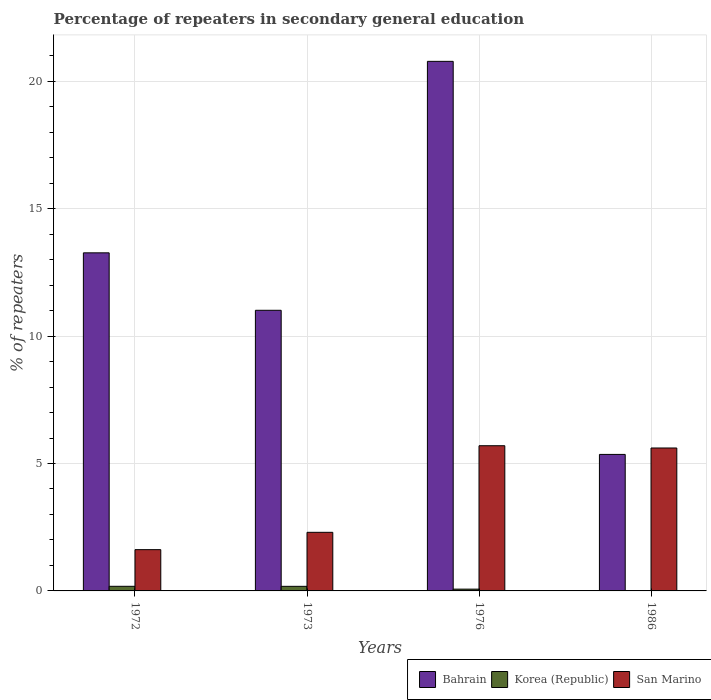Are the number of bars per tick equal to the number of legend labels?
Offer a very short reply. Yes. Are the number of bars on each tick of the X-axis equal?
Your response must be concise. Yes. How many bars are there on the 2nd tick from the right?
Ensure brevity in your answer.  3. In how many cases, is the number of bars for a given year not equal to the number of legend labels?
Make the answer very short. 0. What is the percentage of repeaters in secondary general education in San Marino in 1976?
Your response must be concise. 5.7. Across all years, what is the maximum percentage of repeaters in secondary general education in San Marino?
Your answer should be compact. 5.7. Across all years, what is the minimum percentage of repeaters in secondary general education in Bahrain?
Provide a succinct answer. 5.36. In which year was the percentage of repeaters in secondary general education in San Marino minimum?
Your answer should be very brief. 1972. What is the total percentage of repeaters in secondary general education in Korea (Republic) in the graph?
Your answer should be very brief. 0.44. What is the difference between the percentage of repeaters in secondary general education in Bahrain in 1972 and that in 1973?
Offer a terse response. 2.25. What is the difference between the percentage of repeaters in secondary general education in San Marino in 1986 and the percentage of repeaters in secondary general education in Korea (Republic) in 1972?
Give a very brief answer. 5.43. What is the average percentage of repeaters in secondary general education in Bahrain per year?
Keep it short and to the point. 12.6. In the year 1976, what is the difference between the percentage of repeaters in secondary general education in Korea (Republic) and percentage of repeaters in secondary general education in Bahrain?
Offer a very short reply. -20.71. What is the ratio of the percentage of repeaters in secondary general education in Bahrain in 1973 to that in 1986?
Offer a terse response. 2.06. Is the percentage of repeaters in secondary general education in Bahrain in 1973 less than that in 1986?
Your response must be concise. No. Is the difference between the percentage of repeaters in secondary general education in Korea (Republic) in 1972 and 1976 greater than the difference between the percentage of repeaters in secondary general education in Bahrain in 1972 and 1976?
Give a very brief answer. Yes. What is the difference between the highest and the second highest percentage of repeaters in secondary general education in San Marino?
Make the answer very short. 0.09. What is the difference between the highest and the lowest percentage of repeaters in secondary general education in Bahrain?
Give a very brief answer. 15.42. What does the 1st bar from the right in 1986 represents?
Offer a terse response. San Marino. Is it the case that in every year, the sum of the percentage of repeaters in secondary general education in Bahrain and percentage of repeaters in secondary general education in Korea (Republic) is greater than the percentage of repeaters in secondary general education in San Marino?
Make the answer very short. No. What is the difference between two consecutive major ticks on the Y-axis?
Keep it short and to the point. 5. Does the graph contain any zero values?
Provide a succinct answer. No. Does the graph contain grids?
Offer a terse response. Yes. How are the legend labels stacked?
Make the answer very short. Horizontal. What is the title of the graph?
Your answer should be compact. Percentage of repeaters in secondary general education. What is the label or title of the Y-axis?
Make the answer very short. % of repeaters. What is the % of repeaters in Bahrain in 1972?
Provide a short and direct response. 13.27. What is the % of repeaters of Korea (Republic) in 1972?
Ensure brevity in your answer.  0.18. What is the % of repeaters in San Marino in 1972?
Your response must be concise. 1.62. What is the % of repeaters of Bahrain in 1973?
Your response must be concise. 11.01. What is the % of repeaters in Korea (Republic) in 1973?
Give a very brief answer. 0.18. What is the % of repeaters in San Marino in 1973?
Offer a terse response. 2.3. What is the % of repeaters of Bahrain in 1976?
Provide a succinct answer. 20.78. What is the % of repeaters of Korea (Republic) in 1976?
Provide a succinct answer. 0.07. What is the % of repeaters in San Marino in 1976?
Your answer should be compact. 5.7. What is the % of repeaters of Bahrain in 1986?
Offer a very short reply. 5.36. What is the % of repeaters of Korea (Republic) in 1986?
Offer a very short reply. 0.01. What is the % of repeaters of San Marino in 1986?
Make the answer very short. 5.61. Across all years, what is the maximum % of repeaters in Bahrain?
Offer a very short reply. 20.78. Across all years, what is the maximum % of repeaters of Korea (Republic)?
Your response must be concise. 0.18. Across all years, what is the maximum % of repeaters of San Marino?
Your answer should be compact. 5.7. Across all years, what is the minimum % of repeaters of Bahrain?
Provide a short and direct response. 5.36. Across all years, what is the minimum % of repeaters in Korea (Republic)?
Give a very brief answer. 0.01. Across all years, what is the minimum % of repeaters in San Marino?
Your answer should be very brief. 1.62. What is the total % of repeaters of Bahrain in the graph?
Offer a very short reply. 50.42. What is the total % of repeaters in Korea (Republic) in the graph?
Provide a succinct answer. 0.44. What is the total % of repeaters in San Marino in the graph?
Provide a short and direct response. 15.23. What is the difference between the % of repeaters of Bahrain in 1972 and that in 1973?
Provide a short and direct response. 2.25. What is the difference between the % of repeaters of Korea (Republic) in 1972 and that in 1973?
Offer a terse response. 0. What is the difference between the % of repeaters in San Marino in 1972 and that in 1973?
Your answer should be very brief. -0.68. What is the difference between the % of repeaters in Bahrain in 1972 and that in 1976?
Your answer should be very brief. -7.51. What is the difference between the % of repeaters of Korea (Republic) in 1972 and that in 1976?
Your answer should be compact. 0.11. What is the difference between the % of repeaters of San Marino in 1972 and that in 1976?
Offer a very short reply. -4.08. What is the difference between the % of repeaters in Bahrain in 1972 and that in 1986?
Offer a terse response. 7.91. What is the difference between the % of repeaters in Korea (Republic) in 1972 and that in 1986?
Keep it short and to the point. 0.18. What is the difference between the % of repeaters of San Marino in 1972 and that in 1986?
Make the answer very short. -3.99. What is the difference between the % of repeaters of Bahrain in 1973 and that in 1976?
Give a very brief answer. -9.77. What is the difference between the % of repeaters in Korea (Republic) in 1973 and that in 1976?
Make the answer very short. 0.11. What is the difference between the % of repeaters of San Marino in 1973 and that in 1976?
Provide a short and direct response. -3.4. What is the difference between the % of repeaters in Bahrain in 1973 and that in 1986?
Your response must be concise. 5.66. What is the difference between the % of repeaters of Korea (Republic) in 1973 and that in 1986?
Ensure brevity in your answer.  0.17. What is the difference between the % of repeaters of San Marino in 1973 and that in 1986?
Provide a succinct answer. -3.31. What is the difference between the % of repeaters in Bahrain in 1976 and that in 1986?
Offer a very short reply. 15.42. What is the difference between the % of repeaters in Korea (Republic) in 1976 and that in 1986?
Ensure brevity in your answer.  0.06. What is the difference between the % of repeaters in San Marino in 1976 and that in 1986?
Offer a very short reply. 0.09. What is the difference between the % of repeaters of Bahrain in 1972 and the % of repeaters of Korea (Republic) in 1973?
Keep it short and to the point. 13.09. What is the difference between the % of repeaters of Bahrain in 1972 and the % of repeaters of San Marino in 1973?
Your response must be concise. 10.97. What is the difference between the % of repeaters of Korea (Republic) in 1972 and the % of repeaters of San Marino in 1973?
Make the answer very short. -2.12. What is the difference between the % of repeaters of Bahrain in 1972 and the % of repeaters of Korea (Republic) in 1976?
Make the answer very short. 13.2. What is the difference between the % of repeaters of Bahrain in 1972 and the % of repeaters of San Marino in 1976?
Give a very brief answer. 7.57. What is the difference between the % of repeaters in Korea (Republic) in 1972 and the % of repeaters in San Marino in 1976?
Give a very brief answer. -5.52. What is the difference between the % of repeaters in Bahrain in 1972 and the % of repeaters in Korea (Republic) in 1986?
Offer a very short reply. 13.26. What is the difference between the % of repeaters in Bahrain in 1972 and the % of repeaters in San Marino in 1986?
Keep it short and to the point. 7.66. What is the difference between the % of repeaters of Korea (Republic) in 1972 and the % of repeaters of San Marino in 1986?
Your answer should be compact. -5.43. What is the difference between the % of repeaters of Bahrain in 1973 and the % of repeaters of Korea (Republic) in 1976?
Your response must be concise. 10.94. What is the difference between the % of repeaters of Bahrain in 1973 and the % of repeaters of San Marino in 1976?
Offer a very short reply. 5.31. What is the difference between the % of repeaters of Korea (Republic) in 1973 and the % of repeaters of San Marino in 1976?
Your answer should be compact. -5.52. What is the difference between the % of repeaters of Bahrain in 1973 and the % of repeaters of Korea (Republic) in 1986?
Ensure brevity in your answer.  11.01. What is the difference between the % of repeaters of Bahrain in 1973 and the % of repeaters of San Marino in 1986?
Provide a succinct answer. 5.4. What is the difference between the % of repeaters of Korea (Republic) in 1973 and the % of repeaters of San Marino in 1986?
Provide a short and direct response. -5.43. What is the difference between the % of repeaters in Bahrain in 1976 and the % of repeaters in Korea (Republic) in 1986?
Make the answer very short. 20.78. What is the difference between the % of repeaters in Bahrain in 1976 and the % of repeaters in San Marino in 1986?
Ensure brevity in your answer.  15.17. What is the difference between the % of repeaters of Korea (Republic) in 1976 and the % of repeaters of San Marino in 1986?
Your answer should be very brief. -5.54. What is the average % of repeaters of Bahrain per year?
Offer a terse response. 12.6. What is the average % of repeaters of Korea (Republic) per year?
Make the answer very short. 0.11. What is the average % of repeaters of San Marino per year?
Keep it short and to the point. 3.81. In the year 1972, what is the difference between the % of repeaters in Bahrain and % of repeaters in Korea (Republic)?
Your answer should be compact. 13.09. In the year 1972, what is the difference between the % of repeaters in Bahrain and % of repeaters in San Marino?
Your answer should be very brief. 11.65. In the year 1972, what is the difference between the % of repeaters in Korea (Republic) and % of repeaters in San Marino?
Your answer should be compact. -1.44. In the year 1973, what is the difference between the % of repeaters in Bahrain and % of repeaters in Korea (Republic)?
Give a very brief answer. 10.83. In the year 1973, what is the difference between the % of repeaters in Bahrain and % of repeaters in San Marino?
Provide a short and direct response. 8.71. In the year 1973, what is the difference between the % of repeaters in Korea (Republic) and % of repeaters in San Marino?
Provide a succinct answer. -2.12. In the year 1976, what is the difference between the % of repeaters in Bahrain and % of repeaters in Korea (Republic)?
Offer a very short reply. 20.71. In the year 1976, what is the difference between the % of repeaters in Bahrain and % of repeaters in San Marino?
Your answer should be very brief. 15.08. In the year 1976, what is the difference between the % of repeaters in Korea (Republic) and % of repeaters in San Marino?
Your answer should be compact. -5.63. In the year 1986, what is the difference between the % of repeaters of Bahrain and % of repeaters of Korea (Republic)?
Keep it short and to the point. 5.35. In the year 1986, what is the difference between the % of repeaters in Bahrain and % of repeaters in San Marino?
Your answer should be very brief. -0.25. In the year 1986, what is the difference between the % of repeaters in Korea (Republic) and % of repeaters in San Marino?
Keep it short and to the point. -5.6. What is the ratio of the % of repeaters of Bahrain in 1972 to that in 1973?
Provide a succinct answer. 1.2. What is the ratio of the % of repeaters of Korea (Republic) in 1972 to that in 1973?
Provide a succinct answer. 1.01. What is the ratio of the % of repeaters in San Marino in 1972 to that in 1973?
Ensure brevity in your answer.  0.7. What is the ratio of the % of repeaters in Bahrain in 1972 to that in 1976?
Offer a very short reply. 0.64. What is the ratio of the % of repeaters of Korea (Republic) in 1972 to that in 1976?
Your answer should be compact. 2.58. What is the ratio of the % of repeaters of San Marino in 1972 to that in 1976?
Offer a terse response. 0.28. What is the ratio of the % of repeaters of Bahrain in 1972 to that in 1986?
Your answer should be compact. 2.48. What is the ratio of the % of repeaters of Korea (Republic) in 1972 to that in 1986?
Provide a succinct answer. 31.06. What is the ratio of the % of repeaters of San Marino in 1972 to that in 1986?
Provide a short and direct response. 0.29. What is the ratio of the % of repeaters of Bahrain in 1973 to that in 1976?
Give a very brief answer. 0.53. What is the ratio of the % of repeaters in Korea (Republic) in 1973 to that in 1976?
Make the answer very short. 2.57. What is the ratio of the % of repeaters in San Marino in 1973 to that in 1976?
Offer a terse response. 0.4. What is the ratio of the % of repeaters in Bahrain in 1973 to that in 1986?
Provide a succinct answer. 2.06. What is the ratio of the % of repeaters of Korea (Republic) in 1973 to that in 1986?
Offer a terse response. 30.84. What is the ratio of the % of repeaters of San Marino in 1973 to that in 1986?
Provide a succinct answer. 0.41. What is the ratio of the % of repeaters of Bahrain in 1976 to that in 1986?
Make the answer very short. 3.88. What is the ratio of the % of repeaters in Korea (Republic) in 1976 to that in 1986?
Keep it short and to the point. 12.02. What is the ratio of the % of repeaters of San Marino in 1976 to that in 1986?
Provide a succinct answer. 1.02. What is the difference between the highest and the second highest % of repeaters of Bahrain?
Make the answer very short. 7.51. What is the difference between the highest and the second highest % of repeaters of Korea (Republic)?
Provide a succinct answer. 0. What is the difference between the highest and the second highest % of repeaters of San Marino?
Make the answer very short. 0.09. What is the difference between the highest and the lowest % of repeaters in Bahrain?
Your response must be concise. 15.42. What is the difference between the highest and the lowest % of repeaters of Korea (Republic)?
Offer a very short reply. 0.18. What is the difference between the highest and the lowest % of repeaters in San Marino?
Offer a terse response. 4.08. 